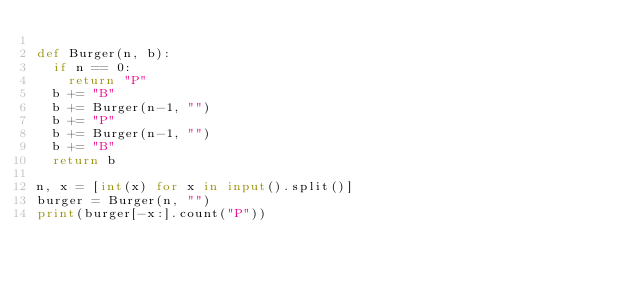<code> <loc_0><loc_0><loc_500><loc_500><_Python_>
def Burger(n, b):
  if n == 0:
    return "P"
  b += "B"
  b += Burger(n-1, "")
  b += "P"
  b += Burger(n-1, "")
  b += "B"
  return b

n, x = [int(x) for x in input().split()]
burger = Burger(n, "")
print(burger[-x:].count("P"))  </code> 